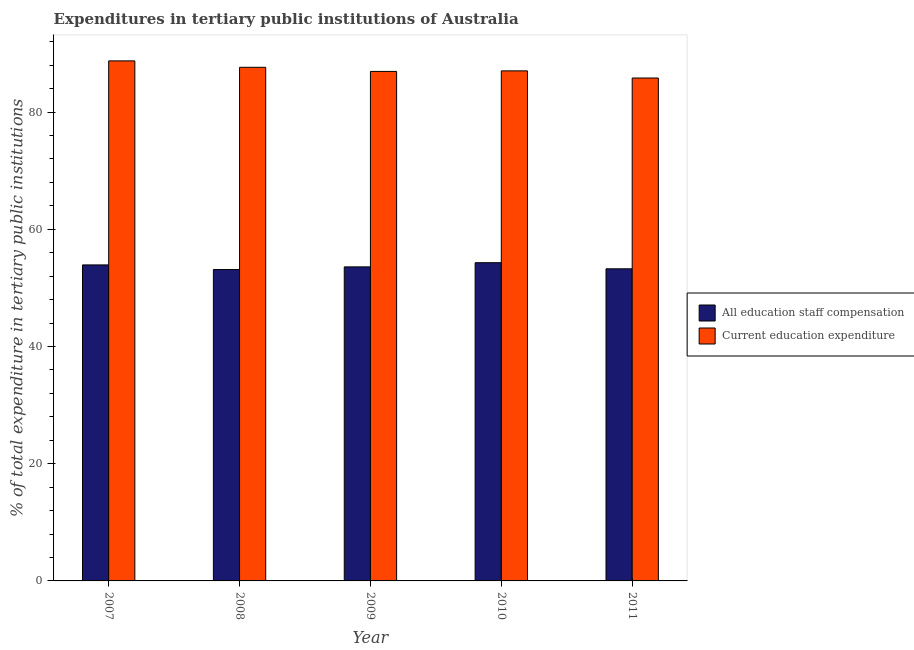How many different coloured bars are there?
Your response must be concise. 2. How many groups of bars are there?
Offer a very short reply. 5. How many bars are there on the 4th tick from the right?
Your answer should be compact. 2. In how many cases, is the number of bars for a given year not equal to the number of legend labels?
Provide a short and direct response. 0. What is the expenditure in staff compensation in 2007?
Provide a short and direct response. 53.91. Across all years, what is the maximum expenditure in staff compensation?
Keep it short and to the point. 54.29. Across all years, what is the minimum expenditure in education?
Keep it short and to the point. 85.8. What is the total expenditure in staff compensation in the graph?
Your answer should be compact. 268.16. What is the difference between the expenditure in staff compensation in 2009 and that in 2011?
Provide a succinct answer. 0.33. What is the difference between the expenditure in staff compensation in 2011 and the expenditure in education in 2009?
Keep it short and to the point. -0.33. What is the average expenditure in education per year?
Offer a terse response. 87.22. What is the ratio of the expenditure in education in 2007 to that in 2008?
Provide a short and direct response. 1.01. Is the difference between the expenditure in staff compensation in 2007 and 2009 greater than the difference between the expenditure in education in 2007 and 2009?
Your answer should be very brief. No. What is the difference between the highest and the second highest expenditure in staff compensation?
Ensure brevity in your answer.  0.38. What is the difference between the highest and the lowest expenditure in staff compensation?
Provide a short and direct response. 1.17. What does the 1st bar from the left in 2008 represents?
Your answer should be very brief. All education staff compensation. What does the 2nd bar from the right in 2009 represents?
Ensure brevity in your answer.  All education staff compensation. Are all the bars in the graph horizontal?
Your response must be concise. No. What is the difference between two consecutive major ticks on the Y-axis?
Your response must be concise. 20. Does the graph contain grids?
Keep it short and to the point. No. How many legend labels are there?
Make the answer very short. 2. What is the title of the graph?
Keep it short and to the point. Expenditures in tertiary public institutions of Australia. What is the label or title of the Y-axis?
Your answer should be compact. % of total expenditure in tertiary public institutions. What is the % of total expenditure in tertiary public institutions of All education staff compensation in 2007?
Ensure brevity in your answer.  53.91. What is the % of total expenditure in tertiary public institutions in Current education expenditure in 2007?
Your answer should be compact. 88.73. What is the % of total expenditure in tertiary public institutions of All education staff compensation in 2008?
Keep it short and to the point. 53.12. What is the % of total expenditure in tertiary public institutions of Current education expenditure in 2008?
Offer a terse response. 87.63. What is the % of total expenditure in tertiary public institutions in All education staff compensation in 2009?
Your answer should be compact. 53.58. What is the % of total expenditure in tertiary public institutions of Current education expenditure in 2009?
Offer a very short reply. 86.93. What is the % of total expenditure in tertiary public institutions in All education staff compensation in 2010?
Your answer should be compact. 54.29. What is the % of total expenditure in tertiary public institutions of Current education expenditure in 2010?
Offer a very short reply. 87.02. What is the % of total expenditure in tertiary public institutions in All education staff compensation in 2011?
Your answer should be very brief. 53.25. What is the % of total expenditure in tertiary public institutions in Current education expenditure in 2011?
Provide a succinct answer. 85.8. Across all years, what is the maximum % of total expenditure in tertiary public institutions of All education staff compensation?
Give a very brief answer. 54.29. Across all years, what is the maximum % of total expenditure in tertiary public institutions of Current education expenditure?
Offer a very short reply. 88.73. Across all years, what is the minimum % of total expenditure in tertiary public institutions in All education staff compensation?
Your answer should be very brief. 53.12. Across all years, what is the minimum % of total expenditure in tertiary public institutions of Current education expenditure?
Make the answer very short. 85.8. What is the total % of total expenditure in tertiary public institutions of All education staff compensation in the graph?
Make the answer very short. 268.16. What is the total % of total expenditure in tertiary public institutions of Current education expenditure in the graph?
Offer a terse response. 436.11. What is the difference between the % of total expenditure in tertiary public institutions of All education staff compensation in 2007 and that in 2008?
Keep it short and to the point. 0.79. What is the difference between the % of total expenditure in tertiary public institutions in Current education expenditure in 2007 and that in 2008?
Give a very brief answer. 1.1. What is the difference between the % of total expenditure in tertiary public institutions of All education staff compensation in 2007 and that in 2009?
Offer a very short reply. 0.34. What is the difference between the % of total expenditure in tertiary public institutions in Current education expenditure in 2007 and that in 2009?
Keep it short and to the point. 1.8. What is the difference between the % of total expenditure in tertiary public institutions of All education staff compensation in 2007 and that in 2010?
Keep it short and to the point. -0.38. What is the difference between the % of total expenditure in tertiary public institutions in Current education expenditure in 2007 and that in 2010?
Ensure brevity in your answer.  1.7. What is the difference between the % of total expenditure in tertiary public institutions of All education staff compensation in 2007 and that in 2011?
Your response must be concise. 0.67. What is the difference between the % of total expenditure in tertiary public institutions of Current education expenditure in 2007 and that in 2011?
Your response must be concise. 2.92. What is the difference between the % of total expenditure in tertiary public institutions of All education staff compensation in 2008 and that in 2009?
Offer a very short reply. -0.45. What is the difference between the % of total expenditure in tertiary public institutions of Current education expenditure in 2008 and that in 2009?
Your answer should be very brief. 0.7. What is the difference between the % of total expenditure in tertiary public institutions of All education staff compensation in 2008 and that in 2010?
Offer a very short reply. -1.17. What is the difference between the % of total expenditure in tertiary public institutions in Current education expenditure in 2008 and that in 2010?
Your answer should be very brief. 0.61. What is the difference between the % of total expenditure in tertiary public institutions in All education staff compensation in 2008 and that in 2011?
Make the answer very short. -0.13. What is the difference between the % of total expenditure in tertiary public institutions of Current education expenditure in 2008 and that in 2011?
Provide a short and direct response. 1.82. What is the difference between the % of total expenditure in tertiary public institutions in All education staff compensation in 2009 and that in 2010?
Your response must be concise. -0.71. What is the difference between the % of total expenditure in tertiary public institutions of Current education expenditure in 2009 and that in 2010?
Provide a succinct answer. -0.09. What is the difference between the % of total expenditure in tertiary public institutions of All education staff compensation in 2009 and that in 2011?
Your answer should be very brief. 0.33. What is the difference between the % of total expenditure in tertiary public institutions in Current education expenditure in 2009 and that in 2011?
Your answer should be very brief. 1.13. What is the difference between the % of total expenditure in tertiary public institutions in All education staff compensation in 2010 and that in 2011?
Your answer should be compact. 1.04. What is the difference between the % of total expenditure in tertiary public institutions in Current education expenditure in 2010 and that in 2011?
Provide a short and direct response. 1.22. What is the difference between the % of total expenditure in tertiary public institutions of All education staff compensation in 2007 and the % of total expenditure in tertiary public institutions of Current education expenditure in 2008?
Keep it short and to the point. -33.71. What is the difference between the % of total expenditure in tertiary public institutions in All education staff compensation in 2007 and the % of total expenditure in tertiary public institutions in Current education expenditure in 2009?
Offer a terse response. -33.01. What is the difference between the % of total expenditure in tertiary public institutions of All education staff compensation in 2007 and the % of total expenditure in tertiary public institutions of Current education expenditure in 2010?
Ensure brevity in your answer.  -33.11. What is the difference between the % of total expenditure in tertiary public institutions of All education staff compensation in 2007 and the % of total expenditure in tertiary public institutions of Current education expenditure in 2011?
Ensure brevity in your answer.  -31.89. What is the difference between the % of total expenditure in tertiary public institutions in All education staff compensation in 2008 and the % of total expenditure in tertiary public institutions in Current education expenditure in 2009?
Make the answer very short. -33.8. What is the difference between the % of total expenditure in tertiary public institutions of All education staff compensation in 2008 and the % of total expenditure in tertiary public institutions of Current education expenditure in 2010?
Make the answer very short. -33.9. What is the difference between the % of total expenditure in tertiary public institutions of All education staff compensation in 2008 and the % of total expenditure in tertiary public institutions of Current education expenditure in 2011?
Make the answer very short. -32.68. What is the difference between the % of total expenditure in tertiary public institutions in All education staff compensation in 2009 and the % of total expenditure in tertiary public institutions in Current education expenditure in 2010?
Your answer should be compact. -33.44. What is the difference between the % of total expenditure in tertiary public institutions in All education staff compensation in 2009 and the % of total expenditure in tertiary public institutions in Current education expenditure in 2011?
Ensure brevity in your answer.  -32.23. What is the difference between the % of total expenditure in tertiary public institutions in All education staff compensation in 2010 and the % of total expenditure in tertiary public institutions in Current education expenditure in 2011?
Provide a short and direct response. -31.51. What is the average % of total expenditure in tertiary public institutions in All education staff compensation per year?
Offer a very short reply. 53.63. What is the average % of total expenditure in tertiary public institutions in Current education expenditure per year?
Make the answer very short. 87.22. In the year 2007, what is the difference between the % of total expenditure in tertiary public institutions of All education staff compensation and % of total expenditure in tertiary public institutions of Current education expenditure?
Give a very brief answer. -34.81. In the year 2008, what is the difference between the % of total expenditure in tertiary public institutions in All education staff compensation and % of total expenditure in tertiary public institutions in Current education expenditure?
Provide a succinct answer. -34.5. In the year 2009, what is the difference between the % of total expenditure in tertiary public institutions in All education staff compensation and % of total expenditure in tertiary public institutions in Current education expenditure?
Make the answer very short. -33.35. In the year 2010, what is the difference between the % of total expenditure in tertiary public institutions of All education staff compensation and % of total expenditure in tertiary public institutions of Current education expenditure?
Offer a very short reply. -32.73. In the year 2011, what is the difference between the % of total expenditure in tertiary public institutions of All education staff compensation and % of total expenditure in tertiary public institutions of Current education expenditure?
Your answer should be very brief. -32.55. What is the ratio of the % of total expenditure in tertiary public institutions in All education staff compensation in 2007 to that in 2008?
Provide a short and direct response. 1.01. What is the ratio of the % of total expenditure in tertiary public institutions in Current education expenditure in 2007 to that in 2008?
Provide a succinct answer. 1.01. What is the ratio of the % of total expenditure in tertiary public institutions of Current education expenditure in 2007 to that in 2009?
Offer a terse response. 1.02. What is the ratio of the % of total expenditure in tertiary public institutions in All education staff compensation in 2007 to that in 2010?
Provide a short and direct response. 0.99. What is the ratio of the % of total expenditure in tertiary public institutions in Current education expenditure in 2007 to that in 2010?
Make the answer very short. 1.02. What is the ratio of the % of total expenditure in tertiary public institutions of All education staff compensation in 2007 to that in 2011?
Keep it short and to the point. 1.01. What is the ratio of the % of total expenditure in tertiary public institutions of Current education expenditure in 2007 to that in 2011?
Your response must be concise. 1.03. What is the ratio of the % of total expenditure in tertiary public institutions in All education staff compensation in 2008 to that in 2009?
Provide a succinct answer. 0.99. What is the ratio of the % of total expenditure in tertiary public institutions in All education staff compensation in 2008 to that in 2010?
Your answer should be compact. 0.98. What is the ratio of the % of total expenditure in tertiary public institutions in Current education expenditure in 2008 to that in 2010?
Give a very brief answer. 1.01. What is the ratio of the % of total expenditure in tertiary public institutions in All education staff compensation in 2008 to that in 2011?
Ensure brevity in your answer.  1. What is the ratio of the % of total expenditure in tertiary public institutions in Current education expenditure in 2008 to that in 2011?
Your response must be concise. 1.02. What is the ratio of the % of total expenditure in tertiary public institutions of Current education expenditure in 2009 to that in 2010?
Give a very brief answer. 1. What is the ratio of the % of total expenditure in tertiary public institutions in All education staff compensation in 2009 to that in 2011?
Provide a succinct answer. 1.01. What is the ratio of the % of total expenditure in tertiary public institutions in Current education expenditure in 2009 to that in 2011?
Your response must be concise. 1.01. What is the ratio of the % of total expenditure in tertiary public institutions in All education staff compensation in 2010 to that in 2011?
Offer a very short reply. 1.02. What is the ratio of the % of total expenditure in tertiary public institutions in Current education expenditure in 2010 to that in 2011?
Your answer should be very brief. 1.01. What is the difference between the highest and the second highest % of total expenditure in tertiary public institutions of All education staff compensation?
Offer a terse response. 0.38. What is the difference between the highest and the second highest % of total expenditure in tertiary public institutions of Current education expenditure?
Provide a short and direct response. 1.1. What is the difference between the highest and the lowest % of total expenditure in tertiary public institutions of All education staff compensation?
Your response must be concise. 1.17. What is the difference between the highest and the lowest % of total expenditure in tertiary public institutions of Current education expenditure?
Give a very brief answer. 2.92. 